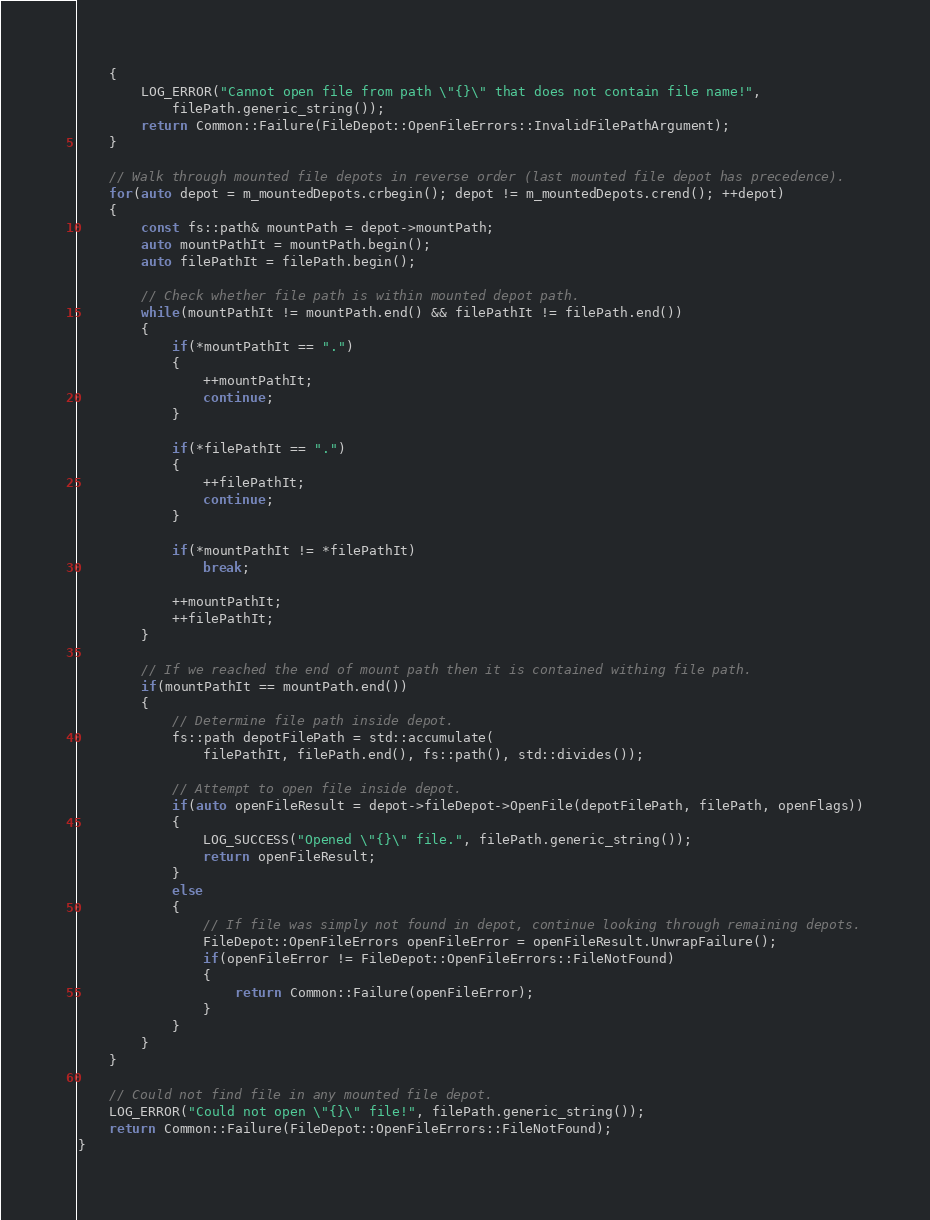Convert code to text. <code><loc_0><loc_0><loc_500><loc_500><_C++_>    {
        LOG_ERROR("Cannot open file from path \"{}\" that does not contain file name!",
            filePath.generic_string());
        return Common::Failure(FileDepot::OpenFileErrors::InvalidFilePathArgument);
    }

    // Walk through mounted file depots in reverse order (last mounted file depot has precedence).
    for(auto depot = m_mountedDepots.crbegin(); depot != m_mountedDepots.crend(); ++depot)
    {
        const fs::path& mountPath = depot->mountPath;
        auto mountPathIt = mountPath.begin();
        auto filePathIt = filePath.begin();

        // Check whether file path is within mounted depot path.
        while(mountPathIt != mountPath.end() && filePathIt != filePath.end())
        {
            if(*mountPathIt == ".")
            {
                ++mountPathIt;
                continue;
            }

            if(*filePathIt == ".")
            {
                ++filePathIt;
                continue;
            }

            if(*mountPathIt != *filePathIt)
                break;

            ++mountPathIt;
            ++filePathIt;
        }

        // If we reached the end of mount path then it is contained withing file path.
        if(mountPathIt == mountPath.end())
        {
            // Determine file path inside depot.
            fs::path depotFilePath = std::accumulate(
                filePathIt, filePath.end(), fs::path(), std::divides());

            // Attempt to open file inside depot.
            if(auto openFileResult = depot->fileDepot->OpenFile(depotFilePath, filePath, openFlags))
            {
                LOG_SUCCESS("Opened \"{}\" file.", filePath.generic_string());
                return openFileResult;
            }
            else
            {
                // If file was simply not found in depot, continue looking through remaining depots.
                FileDepot::OpenFileErrors openFileError = openFileResult.UnwrapFailure();
                if(openFileError != FileDepot::OpenFileErrors::FileNotFound)
                {
                    return Common::Failure(openFileError);
                }
            }
        }
    }

    // Could not find file in any mounted file depot.
    LOG_ERROR("Could not open \"{}\" file!", filePath.generic_string());
    return Common::Failure(FileDepot::OpenFileErrors::FileNotFound);
}
</code> 